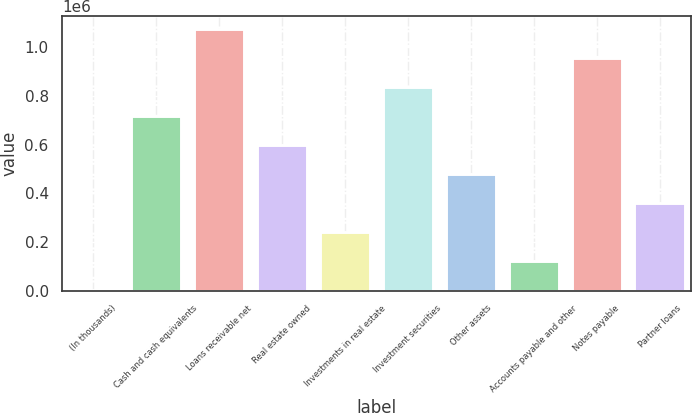Convert chart to OTSL. <chart><loc_0><loc_0><loc_500><loc_500><bar_chart><fcel>(In thousands)<fcel>Cash and cash equivalents<fcel>Loans receivable net<fcel>Real estate owned<fcel>Investments in real estate<fcel>Investment securities<fcel>Other assets<fcel>Accounts payable and other<fcel>Notes payable<fcel>Partner loans<nl><fcel>2013<fcel>716852<fcel>1.07427e+06<fcel>597712<fcel>240293<fcel>835992<fcel>478573<fcel>121153<fcel>955132<fcel>359433<nl></chart> 